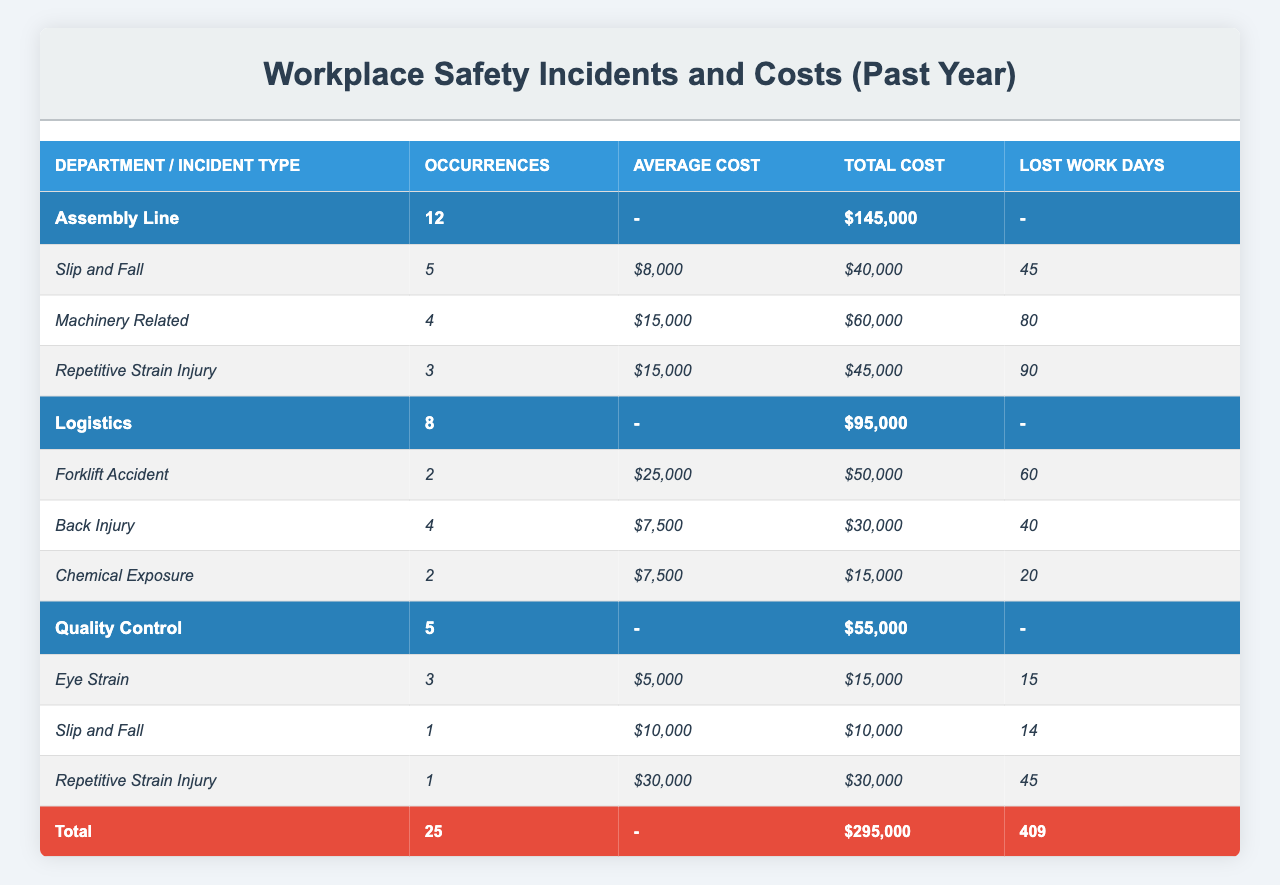What is the total number of workplace safety incidents reported in the Assembly Line department? Refer to the "Assembly Line" row in the Total Incidents column, which shows 12 incidents.
Answer: 12 How much did the company spend on workplace safety incidents in the Logistics department? Look at the "Logistics" row in the Total Cost column, which displays $95,000.
Answer: $95,000 Which type of incident caused the most lost work days in the Assembly Line department? In the Assembly Line section, "Machinery Related" incidents had 80 lost work days – the highest among all types.
Answer: Machinery Related What is the average cost of a slip and fall incident in the Assembly Line department? The average cost for "Slip and Fall" incidents is indicated as $8,000 in the respective row under Average Cost.
Answer: $8,000 How many total lost work days were caused by incidents across all departments? Add the Lost Work Days column totals: 45 (Assembly Line) + 80 + 90 + 60 (Logistics) + 40 + 20 (Chemical Exposure) + 15 (Quality Control) + 14 + 45 = 420 total lost days.
Answer: 420 Did any department have more incidents than the Assembly Line department? Compare the total incidents for the Assembly Line (12) with Logistics (8) and Quality Control (5). No department had more than 12 incidents.
Answer: No What is the total cost for Repetitive Strain Injuries across all departments? From the table, Assembly Line has $45,000 and Quality Control has $30,000. Adding them gives $45,000 + $30,000 = $75,000.
Answer: $75,000 How many incidents of machinery-related injuries occurred across both the Assembly Line and Logistics departments? The Assembly Line had 4 occurrences, and Logistics had 0, totaling 4 incidents of machinery-related injuries.
Answer: 4 What percentage of total costs does the Assembly Line represent of the overall costs from all departments? Total costs are $145,000 (Assembly Line) + $95,000 (Logistics) + $55,000 (Quality Control) = $295,000. The percentage is ($145,000 / $295,000) * 100 ≈ 49.15%.
Answer: ≈ 49.15% Which incident type in Quality Control incurred the highest individual average cost? The highest average cost is found with "Repetitive Strain Injury," which has an average cost of $30,000.
Answer: Repetitive Strain Injury 